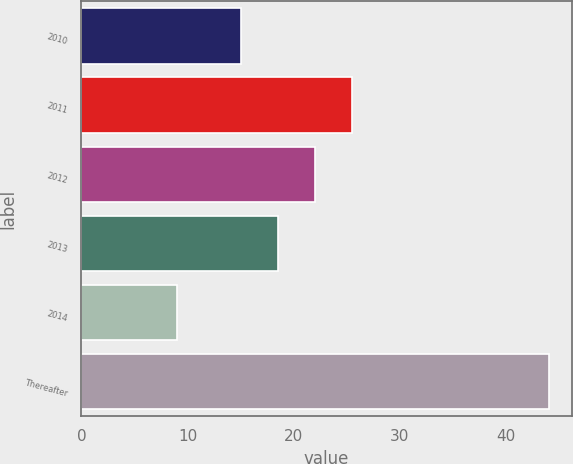<chart> <loc_0><loc_0><loc_500><loc_500><bar_chart><fcel>2010<fcel>2011<fcel>2012<fcel>2013<fcel>2014<fcel>Thereafter<nl><fcel>15<fcel>25.5<fcel>22<fcel>18.5<fcel>9<fcel>44<nl></chart> 